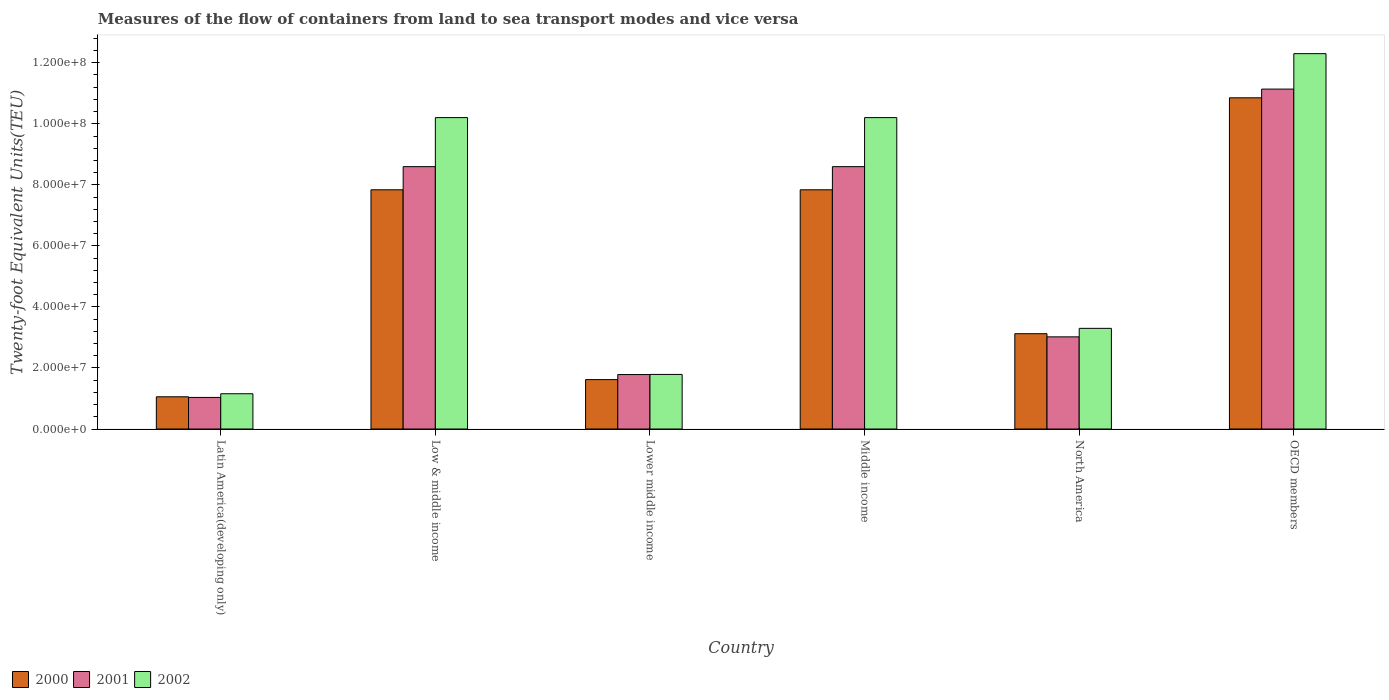How many groups of bars are there?
Your answer should be compact. 6. How many bars are there on the 3rd tick from the right?
Your response must be concise. 3. In how many cases, is the number of bars for a given country not equal to the number of legend labels?
Your answer should be very brief. 0. What is the container port traffic in 2001 in Low & middle income?
Offer a very short reply. 8.60e+07. Across all countries, what is the maximum container port traffic in 2001?
Offer a very short reply. 1.11e+08. Across all countries, what is the minimum container port traffic in 2002?
Provide a succinct answer. 1.16e+07. In which country was the container port traffic in 2001 minimum?
Offer a terse response. Latin America(developing only). What is the total container port traffic in 2002 in the graph?
Make the answer very short. 3.89e+08. What is the difference between the container port traffic in 2002 in Low & middle income and that in North America?
Provide a short and direct response. 6.91e+07. What is the difference between the container port traffic in 2002 in North America and the container port traffic in 2001 in Lower middle income?
Your response must be concise. 1.51e+07. What is the average container port traffic in 2000 per country?
Make the answer very short. 5.39e+07. What is the difference between the container port traffic of/in 2000 and container port traffic of/in 2002 in Middle income?
Offer a very short reply. -2.37e+07. In how many countries, is the container port traffic in 2001 greater than 92000000 TEU?
Offer a terse response. 1. What is the ratio of the container port traffic in 2002 in Lower middle income to that in OECD members?
Give a very brief answer. 0.15. Is the difference between the container port traffic in 2000 in Latin America(developing only) and OECD members greater than the difference between the container port traffic in 2002 in Latin America(developing only) and OECD members?
Give a very brief answer. Yes. What is the difference between the highest and the second highest container port traffic in 2001?
Keep it short and to the point. -2.54e+07. What is the difference between the highest and the lowest container port traffic in 2000?
Your answer should be very brief. 9.80e+07. What does the 2nd bar from the right in North America represents?
Provide a succinct answer. 2001. Is it the case that in every country, the sum of the container port traffic in 2000 and container port traffic in 2002 is greater than the container port traffic in 2001?
Provide a short and direct response. Yes. How many bars are there?
Your answer should be compact. 18. What is the difference between two consecutive major ticks on the Y-axis?
Offer a very short reply. 2.00e+07. Does the graph contain grids?
Make the answer very short. No. How are the legend labels stacked?
Make the answer very short. Horizontal. What is the title of the graph?
Offer a terse response. Measures of the flow of containers from land to sea transport modes and vice versa. What is the label or title of the X-axis?
Offer a terse response. Country. What is the label or title of the Y-axis?
Offer a terse response. Twenty-foot Equivalent Units(TEU). What is the Twenty-foot Equivalent Units(TEU) in 2000 in Latin America(developing only)?
Provide a short and direct response. 1.06e+07. What is the Twenty-foot Equivalent Units(TEU) of 2001 in Latin America(developing only)?
Offer a very short reply. 1.04e+07. What is the Twenty-foot Equivalent Units(TEU) of 2002 in Latin America(developing only)?
Make the answer very short. 1.16e+07. What is the Twenty-foot Equivalent Units(TEU) of 2000 in Low & middle income?
Give a very brief answer. 7.84e+07. What is the Twenty-foot Equivalent Units(TEU) of 2001 in Low & middle income?
Provide a succinct answer. 8.60e+07. What is the Twenty-foot Equivalent Units(TEU) in 2002 in Low & middle income?
Ensure brevity in your answer.  1.02e+08. What is the Twenty-foot Equivalent Units(TEU) in 2000 in Lower middle income?
Your answer should be very brief. 1.62e+07. What is the Twenty-foot Equivalent Units(TEU) of 2001 in Lower middle income?
Provide a succinct answer. 1.78e+07. What is the Twenty-foot Equivalent Units(TEU) of 2002 in Lower middle income?
Offer a terse response. 1.79e+07. What is the Twenty-foot Equivalent Units(TEU) in 2000 in Middle income?
Your answer should be compact. 7.84e+07. What is the Twenty-foot Equivalent Units(TEU) of 2001 in Middle income?
Your answer should be very brief. 8.60e+07. What is the Twenty-foot Equivalent Units(TEU) in 2002 in Middle income?
Give a very brief answer. 1.02e+08. What is the Twenty-foot Equivalent Units(TEU) of 2000 in North America?
Your answer should be compact. 3.12e+07. What is the Twenty-foot Equivalent Units(TEU) in 2001 in North America?
Your answer should be very brief. 3.02e+07. What is the Twenty-foot Equivalent Units(TEU) of 2002 in North America?
Keep it short and to the point. 3.30e+07. What is the Twenty-foot Equivalent Units(TEU) of 2000 in OECD members?
Your answer should be compact. 1.09e+08. What is the Twenty-foot Equivalent Units(TEU) of 2001 in OECD members?
Offer a very short reply. 1.11e+08. What is the Twenty-foot Equivalent Units(TEU) of 2002 in OECD members?
Provide a short and direct response. 1.23e+08. Across all countries, what is the maximum Twenty-foot Equivalent Units(TEU) of 2000?
Offer a terse response. 1.09e+08. Across all countries, what is the maximum Twenty-foot Equivalent Units(TEU) in 2001?
Your answer should be compact. 1.11e+08. Across all countries, what is the maximum Twenty-foot Equivalent Units(TEU) in 2002?
Make the answer very short. 1.23e+08. Across all countries, what is the minimum Twenty-foot Equivalent Units(TEU) in 2000?
Your answer should be very brief. 1.06e+07. Across all countries, what is the minimum Twenty-foot Equivalent Units(TEU) in 2001?
Provide a succinct answer. 1.04e+07. Across all countries, what is the minimum Twenty-foot Equivalent Units(TEU) in 2002?
Keep it short and to the point. 1.16e+07. What is the total Twenty-foot Equivalent Units(TEU) in 2000 in the graph?
Keep it short and to the point. 3.23e+08. What is the total Twenty-foot Equivalent Units(TEU) in 2001 in the graph?
Provide a short and direct response. 3.42e+08. What is the total Twenty-foot Equivalent Units(TEU) in 2002 in the graph?
Your answer should be very brief. 3.89e+08. What is the difference between the Twenty-foot Equivalent Units(TEU) of 2000 in Latin America(developing only) and that in Low & middle income?
Offer a very short reply. -6.78e+07. What is the difference between the Twenty-foot Equivalent Units(TEU) of 2001 in Latin America(developing only) and that in Low & middle income?
Ensure brevity in your answer.  -7.56e+07. What is the difference between the Twenty-foot Equivalent Units(TEU) in 2002 in Latin America(developing only) and that in Low & middle income?
Your response must be concise. -9.05e+07. What is the difference between the Twenty-foot Equivalent Units(TEU) of 2000 in Latin America(developing only) and that in Lower middle income?
Keep it short and to the point. -5.63e+06. What is the difference between the Twenty-foot Equivalent Units(TEU) in 2001 in Latin America(developing only) and that in Lower middle income?
Your answer should be compact. -7.49e+06. What is the difference between the Twenty-foot Equivalent Units(TEU) of 2002 in Latin America(developing only) and that in Lower middle income?
Your answer should be compact. -6.33e+06. What is the difference between the Twenty-foot Equivalent Units(TEU) of 2000 in Latin America(developing only) and that in Middle income?
Give a very brief answer. -6.78e+07. What is the difference between the Twenty-foot Equivalent Units(TEU) in 2001 in Latin America(developing only) and that in Middle income?
Ensure brevity in your answer.  -7.56e+07. What is the difference between the Twenty-foot Equivalent Units(TEU) in 2002 in Latin America(developing only) and that in Middle income?
Ensure brevity in your answer.  -9.05e+07. What is the difference between the Twenty-foot Equivalent Units(TEU) in 2000 in Latin America(developing only) and that in North America?
Your response must be concise. -2.07e+07. What is the difference between the Twenty-foot Equivalent Units(TEU) of 2001 in Latin America(developing only) and that in North America?
Your answer should be very brief. -1.98e+07. What is the difference between the Twenty-foot Equivalent Units(TEU) of 2002 in Latin America(developing only) and that in North America?
Your answer should be compact. -2.14e+07. What is the difference between the Twenty-foot Equivalent Units(TEU) of 2000 in Latin America(developing only) and that in OECD members?
Your answer should be very brief. -9.80e+07. What is the difference between the Twenty-foot Equivalent Units(TEU) of 2001 in Latin America(developing only) and that in OECD members?
Offer a very short reply. -1.01e+08. What is the difference between the Twenty-foot Equivalent Units(TEU) of 2002 in Latin America(developing only) and that in OECD members?
Give a very brief answer. -1.11e+08. What is the difference between the Twenty-foot Equivalent Units(TEU) in 2000 in Low & middle income and that in Lower middle income?
Your answer should be very brief. 6.22e+07. What is the difference between the Twenty-foot Equivalent Units(TEU) of 2001 in Low & middle income and that in Lower middle income?
Provide a succinct answer. 6.81e+07. What is the difference between the Twenty-foot Equivalent Units(TEU) of 2002 in Low & middle income and that in Lower middle income?
Your answer should be very brief. 8.42e+07. What is the difference between the Twenty-foot Equivalent Units(TEU) in 2000 in Low & middle income and that in North America?
Provide a succinct answer. 4.72e+07. What is the difference between the Twenty-foot Equivalent Units(TEU) in 2001 in Low & middle income and that in North America?
Your answer should be very brief. 5.58e+07. What is the difference between the Twenty-foot Equivalent Units(TEU) of 2002 in Low & middle income and that in North America?
Provide a short and direct response. 6.91e+07. What is the difference between the Twenty-foot Equivalent Units(TEU) of 2000 in Low & middle income and that in OECD members?
Give a very brief answer. -3.01e+07. What is the difference between the Twenty-foot Equivalent Units(TEU) of 2001 in Low & middle income and that in OECD members?
Keep it short and to the point. -2.54e+07. What is the difference between the Twenty-foot Equivalent Units(TEU) in 2002 in Low & middle income and that in OECD members?
Offer a very short reply. -2.10e+07. What is the difference between the Twenty-foot Equivalent Units(TEU) in 2000 in Lower middle income and that in Middle income?
Make the answer very short. -6.22e+07. What is the difference between the Twenty-foot Equivalent Units(TEU) of 2001 in Lower middle income and that in Middle income?
Provide a succinct answer. -6.81e+07. What is the difference between the Twenty-foot Equivalent Units(TEU) in 2002 in Lower middle income and that in Middle income?
Provide a succinct answer. -8.42e+07. What is the difference between the Twenty-foot Equivalent Units(TEU) of 2000 in Lower middle income and that in North America?
Make the answer very short. -1.50e+07. What is the difference between the Twenty-foot Equivalent Units(TEU) in 2001 in Lower middle income and that in North America?
Provide a short and direct response. -1.24e+07. What is the difference between the Twenty-foot Equivalent Units(TEU) of 2002 in Lower middle income and that in North America?
Offer a terse response. -1.51e+07. What is the difference between the Twenty-foot Equivalent Units(TEU) of 2000 in Lower middle income and that in OECD members?
Provide a short and direct response. -9.23e+07. What is the difference between the Twenty-foot Equivalent Units(TEU) of 2001 in Lower middle income and that in OECD members?
Ensure brevity in your answer.  -9.35e+07. What is the difference between the Twenty-foot Equivalent Units(TEU) of 2002 in Lower middle income and that in OECD members?
Ensure brevity in your answer.  -1.05e+08. What is the difference between the Twenty-foot Equivalent Units(TEU) in 2000 in Middle income and that in North America?
Give a very brief answer. 4.72e+07. What is the difference between the Twenty-foot Equivalent Units(TEU) of 2001 in Middle income and that in North America?
Offer a terse response. 5.58e+07. What is the difference between the Twenty-foot Equivalent Units(TEU) in 2002 in Middle income and that in North America?
Your answer should be very brief. 6.91e+07. What is the difference between the Twenty-foot Equivalent Units(TEU) in 2000 in Middle income and that in OECD members?
Provide a short and direct response. -3.01e+07. What is the difference between the Twenty-foot Equivalent Units(TEU) in 2001 in Middle income and that in OECD members?
Your answer should be compact. -2.54e+07. What is the difference between the Twenty-foot Equivalent Units(TEU) in 2002 in Middle income and that in OECD members?
Your answer should be very brief. -2.10e+07. What is the difference between the Twenty-foot Equivalent Units(TEU) of 2000 in North America and that in OECD members?
Your answer should be compact. -7.73e+07. What is the difference between the Twenty-foot Equivalent Units(TEU) in 2001 in North America and that in OECD members?
Make the answer very short. -8.12e+07. What is the difference between the Twenty-foot Equivalent Units(TEU) in 2002 in North America and that in OECD members?
Your answer should be very brief. -9.00e+07. What is the difference between the Twenty-foot Equivalent Units(TEU) of 2000 in Latin America(developing only) and the Twenty-foot Equivalent Units(TEU) of 2001 in Low & middle income?
Your answer should be very brief. -7.54e+07. What is the difference between the Twenty-foot Equivalent Units(TEU) of 2000 in Latin America(developing only) and the Twenty-foot Equivalent Units(TEU) of 2002 in Low & middle income?
Ensure brevity in your answer.  -9.15e+07. What is the difference between the Twenty-foot Equivalent Units(TEU) in 2001 in Latin America(developing only) and the Twenty-foot Equivalent Units(TEU) in 2002 in Low & middle income?
Your answer should be compact. -9.17e+07. What is the difference between the Twenty-foot Equivalent Units(TEU) of 2000 in Latin America(developing only) and the Twenty-foot Equivalent Units(TEU) of 2001 in Lower middle income?
Give a very brief answer. -7.29e+06. What is the difference between the Twenty-foot Equivalent Units(TEU) of 2000 in Latin America(developing only) and the Twenty-foot Equivalent Units(TEU) of 2002 in Lower middle income?
Your answer should be very brief. -7.32e+06. What is the difference between the Twenty-foot Equivalent Units(TEU) of 2001 in Latin America(developing only) and the Twenty-foot Equivalent Units(TEU) of 2002 in Lower middle income?
Provide a short and direct response. -7.53e+06. What is the difference between the Twenty-foot Equivalent Units(TEU) in 2000 in Latin America(developing only) and the Twenty-foot Equivalent Units(TEU) in 2001 in Middle income?
Offer a terse response. -7.54e+07. What is the difference between the Twenty-foot Equivalent Units(TEU) in 2000 in Latin America(developing only) and the Twenty-foot Equivalent Units(TEU) in 2002 in Middle income?
Ensure brevity in your answer.  -9.15e+07. What is the difference between the Twenty-foot Equivalent Units(TEU) of 2001 in Latin America(developing only) and the Twenty-foot Equivalent Units(TEU) of 2002 in Middle income?
Your answer should be compact. -9.17e+07. What is the difference between the Twenty-foot Equivalent Units(TEU) in 2000 in Latin America(developing only) and the Twenty-foot Equivalent Units(TEU) in 2001 in North America?
Your answer should be compact. -1.96e+07. What is the difference between the Twenty-foot Equivalent Units(TEU) in 2000 in Latin America(developing only) and the Twenty-foot Equivalent Units(TEU) in 2002 in North America?
Offer a very short reply. -2.24e+07. What is the difference between the Twenty-foot Equivalent Units(TEU) of 2001 in Latin America(developing only) and the Twenty-foot Equivalent Units(TEU) of 2002 in North America?
Your answer should be very brief. -2.26e+07. What is the difference between the Twenty-foot Equivalent Units(TEU) of 2000 in Latin America(developing only) and the Twenty-foot Equivalent Units(TEU) of 2001 in OECD members?
Give a very brief answer. -1.01e+08. What is the difference between the Twenty-foot Equivalent Units(TEU) of 2000 in Latin America(developing only) and the Twenty-foot Equivalent Units(TEU) of 2002 in OECD members?
Keep it short and to the point. -1.12e+08. What is the difference between the Twenty-foot Equivalent Units(TEU) in 2001 in Latin America(developing only) and the Twenty-foot Equivalent Units(TEU) in 2002 in OECD members?
Provide a short and direct response. -1.13e+08. What is the difference between the Twenty-foot Equivalent Units(TEU) of 2000 in Low & middle income and the Twenty-foot Equivalent Units(TEU) of 2001 in Lower middle income?
Keep it short and to the point. 6.05e+07. What is the difference between the Twenty-foot Equivalent Units(TEU) in 2000 in Low & middle income and the Twenty-foot Equivalent Units(TEU) in 2002 in Lower middle income?
Your response must be concise. 6.05e+07. What is the difference between the Twenty-foot Equivalent Units(TEU) of 2001 in Low & middle income and the Twenty-foot Equivalent Units(TEU) of 2002 in Lower middle income?
Provide a succinct answer. 6.81e+07. What is the difference between the Twenty-foot Equivalent Units(TEU) of 2000 in Low & middle income and the Twenty-foot Equivalent Units(TEU) of 2001 in Middle income?
Give a very brief answer. -7.58e+06. What is the difference between the Twenty-foot Equivalent Units(TEU) of 2000 in Low & middle income and the Twenty-foot Equivalent Units(TEU) of 2002 in Middle income?
Offer a terse response. -2.37e+07. What is the difference between the Twenty-foot Equivalent Units(TEU) of 2001 in Low & middle income and the Twenty-foot Equivalent Units(TEU) of 2002 in Middle income?
Ensure brevity in your answer.  -1.61e+07. What is the difference between the Twenty-foot Equivalent Units(TEU) of 2000 in Low & middle income and the Twenty-foot Equivalent Units(TEU) of 2001 in North America?
Your answer should be very brief. 4.82e+07. What is the difference between the Twenty-foot Equivalent Units(TEU) of 2000 in Low & middle income and the Twenty-foot Equivalent Units(TEU) of 2002 in North America?
Your response must be concise. 4.54e+07. What is the difference between the Twenty-foot Equivalent Units(TEU) of 2001 in Low & middle income and the Twenty-foot Equivalent Units(TEU) of 2002 in North America?
Offer a terse response. 5.30e+07. What is the difference between the Twenty-foot Equivalent Units(TEU) of 2000 in Low & middle income and the Twenty-foot Equivalent Units(TEU) of 2001 in OECD members?
Keep it short and to the point. -3.30e+07. What is the difference between the Twenty-foot Equivalent Units(TEU) of 2000 in Low & middle income and the Twenty-foot Equivalent Units(TEU) of 2002 in OECD members?
Offer a terse response. -4.46e+07. What is the difference between the Twenty-foot Equivalent Units(TEU) in 2001 in Low & middle income and the Twenty-foot Equivalent Units(TEU) in 2002 in OECD members?
Keep it short and to the point. -3.70e+07. What is the difference between the Twenty-foot Equivalent Units(TEU) in 2000 in Lower middle income and the Twenty-foot Equivalent Units(TEU) in 2001 in Middle income?
Your answer should be very brief. -6.98e+07. What is the difference between the Twenty-foot Equivalent Units(TEU) in 2000 in Lower middle income and the Twenty-foot Equivalent Units(TEU) in 2002 in Middle income?
Provide a short and direct response. -8.59e+07. What is the difference between the Twenty-foot Equivalent Units(TEU) in 2001 in Lower middle income and the Twenty-foot Equivalent Units(TEU) in 2002 in Middle income?
Your answer should be compact. -8.42e+07. What is the difference between the Twenty-foot Equivalent Units(TEU) of 2000 in Lower middle income and the Twenty-foot Equivalent Units(TEU) of 2001 in North America?
Provide a succinct answer. -1.40e+07. What is the difference between the Twenty-foot Equivalent Units(TEU) of 2000 in Lower middle income and the Twenty-foot Equivalent Units(TEU) of 2002 in North America?
Make the answer very short. -1.68e+07. What is the difference between the Twenty-foot Equivalent Units(TEU) in 2001 in Lower middle income and the Twenty-foot Equivalent Units(TEU) in 2002 in North America?
Give a very brief answer. -1.51e+07. What is the difference between the Twenty-foot Equivalent Units(TEU) of 2000 in Lower middle income and the Twenty-foot Equivalent Units(TEU) of 2001 in OECD members?
Provide a succinct answer. -9.52e+07. What is the difference between the Twenty-foot Equivalent Units(TEU) in 2000 in Lower middle income and the Twenty-foot Equivalent Units(TEU) in 2002 in OECD members?
Offer a terse response. -1.07e+08. What is the difference between the Twenty-foot Equivalent Units(TEU) in 2001 in Lower middle income and the Twenty-foot Equivalent Units(TEU) in 2002 in OECD members?
Your answer should be compact. -1.05e+08. What is the difference between the Twenty-foot Equivalent Units(TEU) in 2000 in Middle income and the Twenty-foot Equivalent Units(TEU) in 2001 in North America?
Give a very brief answer. 4.82e+07. What is the difference between the Twenty-foot Equivalent Units(TEU) in 2000 in Middle income and the Twenty-foot Equivalent Units(TEU) in 2002 in North America?
Give a very brief answer. 4.54e+07. What is the difference between the Twenty-foot Equivalent Units(TEU) in 2001 in Middle income and the Twenty-foot Equivalent Units(TEU) in 2002 in North America?
Ensure brevity in your answer.  5.30e+07. What is the difference between the Twenty-foot Equivalent Units(TEU) of 2000 in Middle income and the Twenty-foot Equivalent Units(TEU) of 2001 in OECD members?
Ensure brevity in your answer.  -3.30e+07. What is the difference between the Twenty-foot Equivalent Units(TEU) in 2000 in Middle income and the Twenty-foot Equivalent Units(TEU) in 2002 in OECD members?
Your answer should be very brief. -4.46e+07. What is the difference between the Twenty-foot Equivalent Units(TEU) in 2001 in Middle income and the Twenty-foot Equivalent Units(TEU) in 2002 in OECD members?
Ensure brevity in your answer.  -3.70e+07. What is the difference between the Twenty-foot Equivalent Units(TEU) of 2000 in North America and the Twenty-foot Equivalent Units(TEU) of 2001 in OECD members?
Offer a terse response. -8.01e+07. What is the difference between the Twenty-foot Equivalent Units(TEU) in 2000 in North America and the Twenty-foot Equivalent Units(TEU) in 2002 in OECD members?
Give a very brief answer. -9.18e+07. What is the difference between the Twenty-foot Equivalent Units(TEU) of 2001 in North America and the Twenty-foot Equivalent Units(TEU) of 2002 in OECD members?
Give a very brief answer. -9.28e+07. What is the average Twenty-foot Equivalent Units(TEU) in 2000 per country?
Give a very brief answer. 5.39e+07. What is the average Twenty-foot Equivalent Units(TEU) of 2001 per country?
Give a very brief answer. 5.69e+07. What is the average Twenty-foot Equivalent Units(TEU) of 2002 per country?
Give a very brief answer. 6.49e+07. What is the difference between the Twenty-foot Equivalent Units(TEU) in 2000 and Twenty-foot Equivalent Units(TEU) in 2001 in Latin America(developing only)?
Your answer should be very brief. 2.09e+05. What is the difference between the Twenty-foot Equivalent Units(TEU) of 2000 and Twenty-foot Equivalent Units(TEU) of 2002 in Latin America(developing only)?
Offer a terse response. -9.97e+05. What is the difference between the Twenty-foot Equivalent Units(TEU) of 2001 and Twenty-foot Equivalent Units(TEU) of 2002 in Latin America(developing only)?
Offer a very short reply. -1.21e+06. What is the difference between the Twenty-foot Equivalent Units(TEU) in 2000 and Twenty-foot Equivalent Units(TEU) in 2001 in Low & middle income?
Your answer should be very brief. -7.58e+06. What is the difference between the Twenty-foot Equivalent Units(TEU) of 2000 and Twenty-foot Equivalent Units(TEU) of 2002 in Low & middle income?
Make the answer very short. -2.37e+07. What is the difference between the Twenty-foot Equivalent Units(TEU) in 2001 and Twenty-foot Equivalent Units(TEU) in 2002 in Low & middle income?
Provide a short and direct response. -1.61e+07. What is the difference between the Twenty-foot Equivalent Units(TEU) of 2000 and Twenty-foot Equivalent Units(TEU) of 2001 in Lower middle income?
Offer a very short reply. -1.66e+06. What is the difference between the Twenty-foot Equivalent Units(TEU) of 2000 and Twenty-foot Equivalent Units(TEU) of 2002 in Lower middle income?
Ensure brevity in your answer.  -1.70e+06. What is the difference between the Twenty-foot Equivalent Units(TEU) of 2001 and Twenty-foot Equivalent Units(TEU) of 2002 in Lower middle income?
Offer a terse response. -3.79e+04. What is the difference between the Twenty-foot Equivalent Units(TEU) of 2000 and Twenty-foot Equivalent Units(TEU) of 2001 in Middle income?
Your answer should be compact. -7.58e+06. What is the difference between the Twenty-foot Equivalent Units(TEU) in 2000 and Twenty-foot Equivalent Units(TEU) in 2002 in Middle income?
Your answer should be compact. -2.37e+07. What is the difference between the Twenty-foot Equivalent Units(TEU) of 2001 and Twenty-foot Equivalent Units(TEU) of 2002 in Middle income?
Your answer should be very brief. -1.61e+07. What is the difference between the Twenty-foot Equivalent Units(TEU) in 2000 and Twenty-foot Equivalent Units(TEU) in 2001 in North America?
Keep it short and to the point. 1.03e+06. What is the difference between the Twenty-foot Equivalent Units(TEU) in 2000 and Twenty-foot Equivalent Units(TEU) in 2002 in North America?
Make the answer very short. -1.76e+06. What is the difference between the Twenty-foot Equivalent Units(TEU) in 2001 and Twenty-foot Equivalent Units(TEU) in 2002 in North America?
Offer a very short reply. -2.79e+06. What is the difference between the Twenty-foot Equivalent Units(TEU) of 2000 and Twenty-foot Equivalent Units(TEU) of 2001 in OECD members?
Keep it short and to the point. -2.86e+06. What is the difference between the Twenty-foot Equivalent Units(TEU) of 2000 and Twenty-foot Equivalent Units(TEU) of 2002 in OECD members?
Offer a terse response. -1.45e+07. What is the difference between the Twenty-foot Equivalent Units(TEU) of 2001 and Twenty-foot Equivalent Units(TEU) of 2002 in OECD members?
Your answer should be compact. -1.16e+07. What is the ratio of the Twenty-foot Equivalent Units(TEU) of 2000 in Latin America(developing only) to that in Low & middle income?
Provide a short and direct response. 0.13. What is the ratio of the Twenty-foot Equivalent Units(TEU) in 2001 in Latin America(developing only) to that in Low & middle income?
Give a very brief answer. 0.12. What is the ratio of the Twenty-foot Equivalent Units(TEU) of 2002 in Latin America(developing only) to that in Low & middle income?
Offer a terse response. 0.11. What is the ratio of the Twenty-foot Equivalent Units(TEU) of 2000 in Latin America(developing only) to that in Lower middle income?
Ensure brevity in your answer.  0.65. What is the ratio of the Twenty-foot Equivalent Units(TEU) in 2001 in Latin America(developing only) to that in Lower middle income?
Offer a very short reply. 0.58. What is the ratio of the Twenty-foot Equivalent Units(TEU) of 2002 in Latin America(developing only) to that in Lower middle income?
Your response must be concise. 0.65. What is the ratio of the Twenty-foot Equivalent Units(TEU) of 2000 in Latin America(developing only) to that in Middle income?
Offer a terse response. 0.13. What is the ratio of the Twenty-foot Equivalent Units(TEU) in 2001 in Latin America(developing only) to that in Middle income?
Offer a very short reply. 0.12. What is the ratio of the Twenty-foot Equivalent Units(TEU) in 2002 in Latin America(developing only) to that in Middle income?
Offer a terse response. 0.11. What is the ratio of the Twenty-foot Equivalent Units(TEU) of 2000 in Latin America(developing only) to that in North America?
Your answer should be compact. 0.34. What is the ratio of the Twenty-foot Equivalent Units(TEU) in 2001 in Latin America(developing only) to that in North America?
Ensure brevity in your answer.  0.34. What is the ratio of the Twenty-foot Equivalent Units(TEU) in 2002 in Latin America(developing only) to that in North America?
Your response must be concise. 0.35. What is the ratio of the Twenty-foot Equivalent Units(TEU) of 2000 in Latin America(developing only) to that in OECD members?
Give a very brief answer. 0.1. What is the ratio of the Twenty-foot Equivalent Units(TEU) of 2001 in Latin America(developing only) to that in OECD members?
Offer a terse response. 0.09. What is the ratio of the Twenty-foot Equivalent Units(TEU) of 2002 in Latin America(developing only) to that in OECD members?
Provide a short and direct response. 0.09. What is the ratio of the Twenty-foot Equivalent Units(TEU) in 2000 in Low & middle income to that in Lower middle income?
Make the answer very short. 4.84. What is the ratio of the Twenty-foot Equivalent Units(TEU) in 2001 in Low & middle income to that in Lower middle income?
Ensure brevity in your answer.  4.82. What is the ratio of the Twenty-foot Equivalent Units(TEU) of 2002 in Low & middle income to that in Lower middle income?
Make the answer very short. 5.71. What is the ratio of the Twenty-foot Equivalent Units(TEU) of 2001 in Low & middle income to that in Middle income?
Provide a short and direct response. 1. What is the ratio of the Twenty-foot Equivalent Units(TEU) of 2000 in Low & middle income to that in North America?
Keep it short and to the point. 2.51. What is the ratio of the Twenty-foot Equivalent Units(TEU) in 2001 in Low & middle income to that in North America?
Keep it short and to the point. 2.85. What is the ratio of the Twenty-foot Equivalent Units(TEU) in 2002 in Low & middle income to that in North America?
Provide a short and direct response. 3.09. What is the ratio of the Twenty-foot Equivalent Units(TEU) in 2000 in Low & middle income to that in OECD members?
Your answer should be very brief. 0.72. What is the ratio of the Twenty-foot Equivalent Units(TEU) in 2001 in Low & middle income to that in OECD members?
Ensure brevity in your answer.  0.77. What is the ratio of the Twenty-foot Equivalent Units(TEU) of 2002 in Low & middle income to that in OECD members?
Offer a terse response. 0.83. What is the ratio of the Twenty-foot Equivalent Units(TEU) of 2000 in Lower middle income to that in Middle income?
Provide a succinct answer. 0.21. What is the ratio of the Twenty-foot Equivalent Units(TEU) of 2001 in Lower middle income to that in Middle income?
Offer a very short reply. 0.21. What is the ratio of the Twenty-foot Equivalent Units(TEU) in 2002 in Lower middle income to that in Middle income?
Ensure brevity in your answer.  0.18. What is the ratio of the Twenty-foot Equivalent Units(TEU) of 2000 in Lower middle income to that in North America?
Ensure brevity in your answer.  0.52. What is the ratio of the Twenty-foot Equivalent Units(TEU) in 2001 in Lower middle income to that in North America?
Keep it short and to the point. 0.59. What is the ratio of the Twenty-foot Equivalent Units(TEU) in 2002 in Lower middle income to that in North America?
Your answer should be compact. 0.54. What is the ratio of the Twenty-foot Equivalent Units(TEU) in 2000 in Lower middle income to that in OECD members?
Provide a short and direct response. 0.15. What is the ratio of the Twenty-foot Equivalent Units(TEU) of 2001 in Lower middle income to that in OECD members?
Offer a very short reply. 0.16. What is the ratio of the Twenty-foot Equivalent Units(TEU) of 2002 in Lower middle income to that in OECD members?
Keep it short and to the point. 0.15. What is the ratio of the Twenty-foot Equivalent Units(TEU) of 2000 in Middle income to that in North America?
Your response must be concise. 2.51. What is the ratio of the Twenty-foot Equivalent Units(TEU) in 2001 in Middle income to that in North America?
Give a very brief answer. 2.85. What is the ratio of the Twenty-foot Equivalent Units(TEU) in 2002 in Middle income to that in North America?
Your answer should be very brief. 3.09. What is the ratio of the Twenty-foot Equivalent Units(TEU) in 2000 in Middle income to that in OECD members?
Ensure brevity in your answer.  0.72. What is the ratio of the Twenty-foot Equivalent Units(TEU) of 2001 in Middle income to that in OECD members?
Your answer should be compact. 0.77. What is the ratio of the Twenty-foot Equivalent Units(TEU) in 2002 in Middle income to that in OECD members?
Provide a short and direct response. 0.83. What is the ratio of the Twenty-foot Equivalent Units(TEU) of 2000 in North America to that in OECD members?
Provide a short and direct response. 0.29. What is the ratio of the Twenty-foot Equivalent Units(TEU) in 2001 in North America to that in OECD members?
Ensure brevity in your answer.  0.27. What is the ratio of the Twenty-foot Equivalent Units(TEU) of 2002 in North America to that in OECD members?
Provide a succinct answer. 0.27. What is the difference between the highest and the second highest Twenty-foot Equivalent Units(TEU) of 2000?
Ensure brevity in your answer.  3.01e+07. What is the difference between the highest and the second highest Twenty-foot Equivalent Units(TEU) in 2001?
Your response must be concise. 2.54e+07. What is the difference between the highest and the second highest Twenty-foot Equivalent Units(TEU) of 2002?
Offer a very short reply. 2.10e+07. What is the difference between the highest and the lowest Twenty-foot Equivalent Units(TEU) in 2000?
Ensure brevity in your answer.  9.80e+07. What is the difference between the highest and the lowest Twenty-foot Equivalent Units(TEU) in 2001?
Your response must be concise. 1.01e+08. What is the difference between the highest and the lowest Twenty-foot Equivalent Units(TEU) of 2002?
Your answer should be very brief. 1.11e+08. 